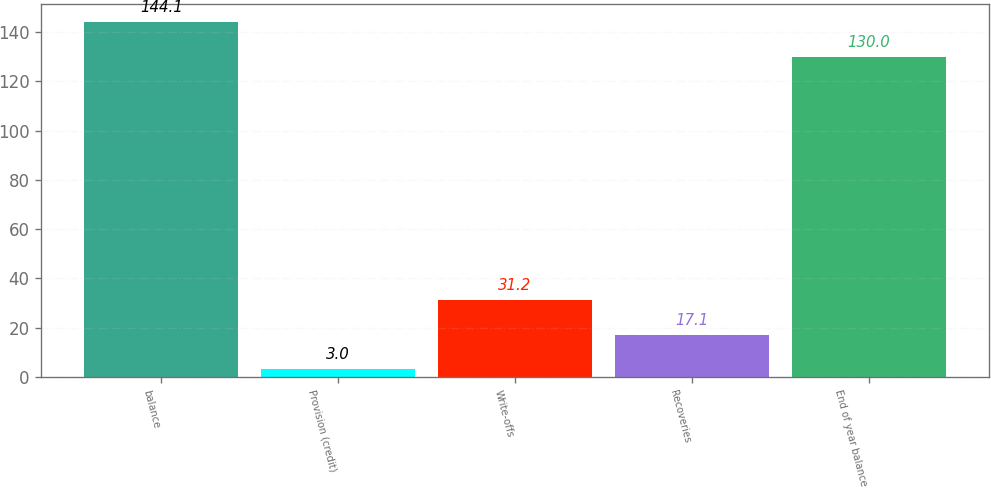<chart> <loc_0><loc_0><loc_500><loc_500><bar_chart><fcel>balance<fcel>Provision (credit)<fcel>Write-offs<fcel>Recoveries<fcel>End of year balance<nl><fcel>144.1<fcel>3<fcel>31.2<fcel>17.1<fcel>130<nl></chart> 